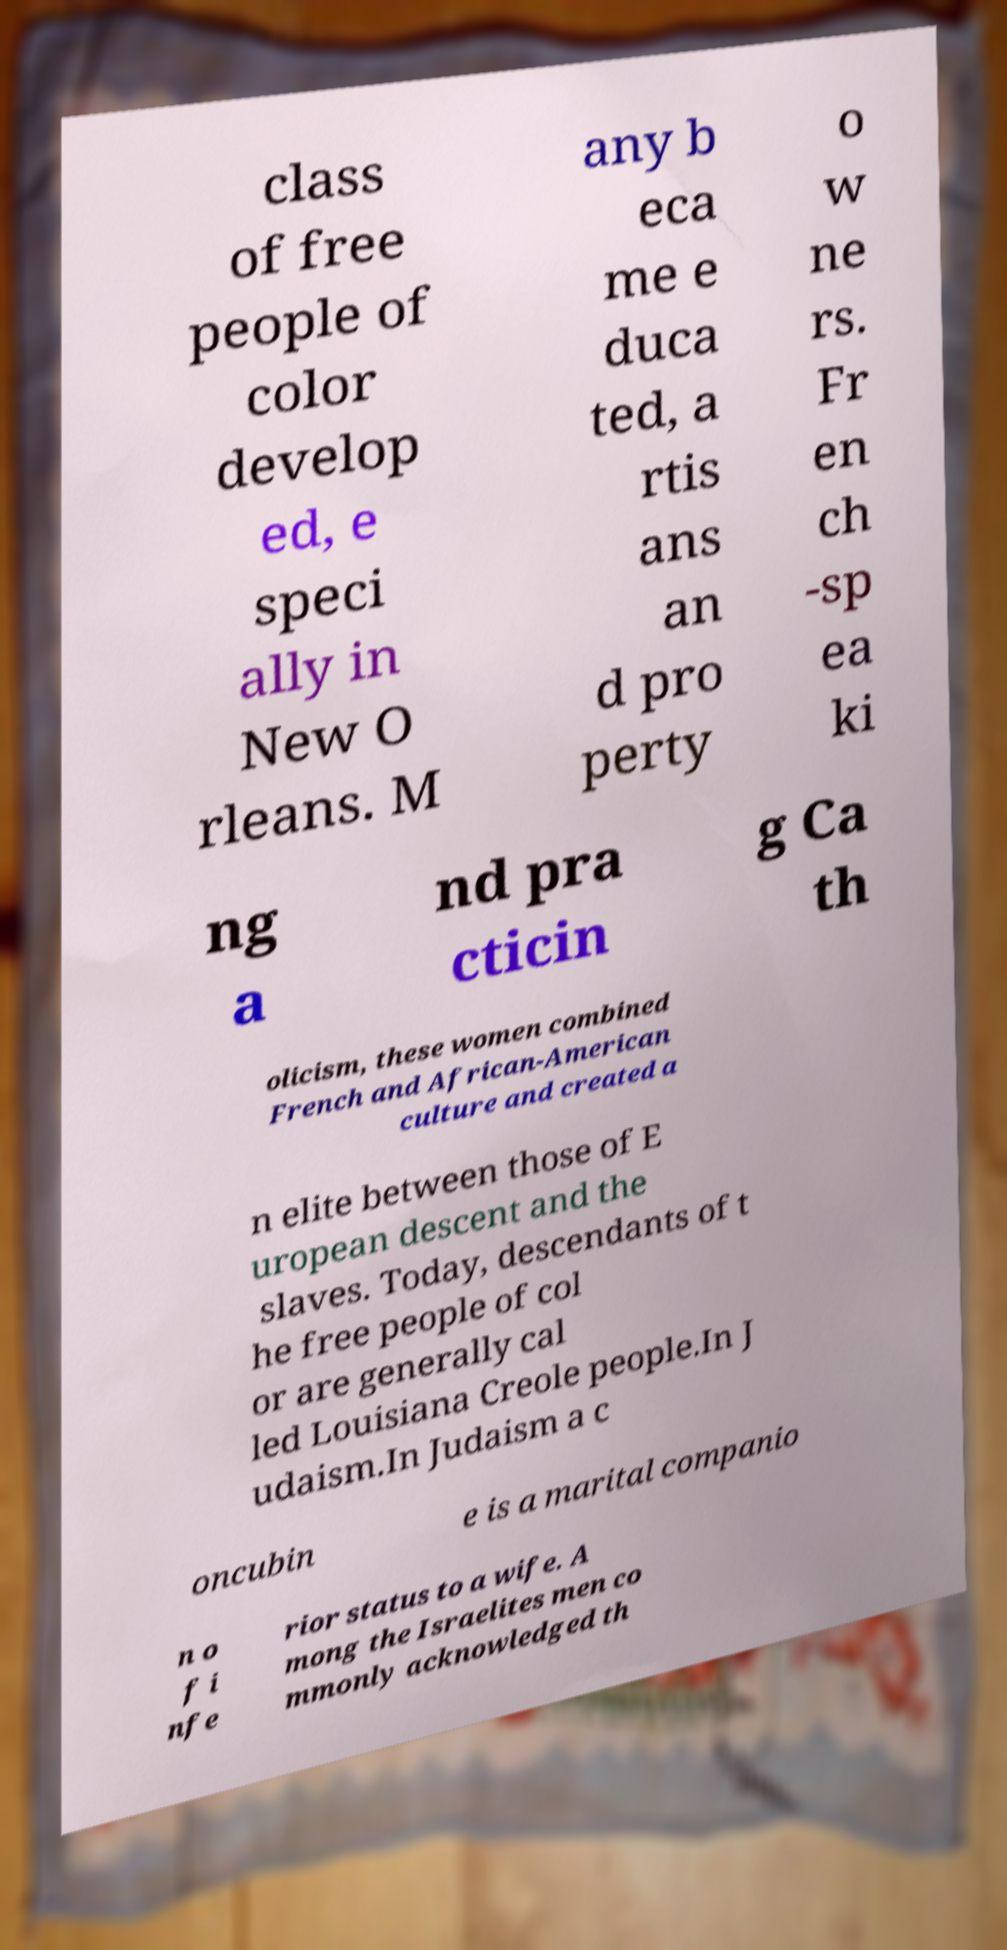Please identify and transcribe the text found in this image. class of free people of color develop ed, e speci ally in New O rleans. M any b eca me e duca ted, a rtis ans an d pro perty o w ne rs. Fr en ch -sp ea ki ng a nd pra cticin g Ca th olicism, these women combined French and African-American culture and created a n elite between those of E uropean descent and the slaves. Today, descendants of t he free people of col or are generally cal led Louisiana Creole people.In J udaism.In Judaism a c oncubin e is a marital companio n o f i nfe rior status to a wife. A mong the Israelites men co mmonly acknowledged th 